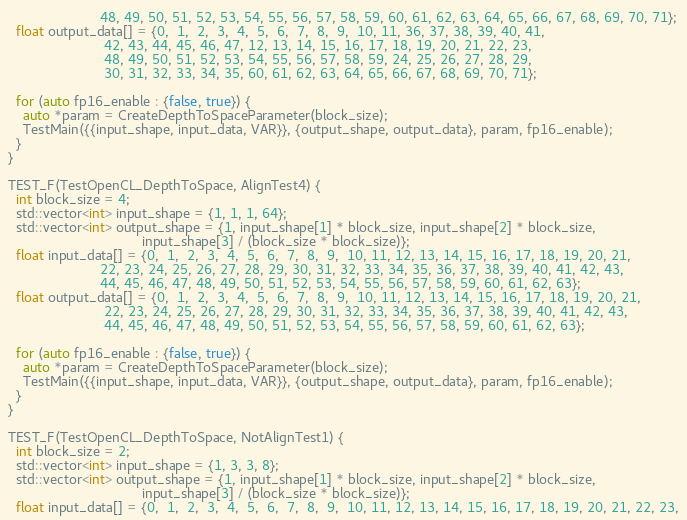<code> <loc_0><loc_0><loc_500><loc_500><_C++_>                        48, 49, 50, 51, 52, 53, 54, 55, 56, 57, 58, 59, 60, 61, 62, 63, 64, 65, 66, 67, 68, 69, 70, 71};
  float output_data[] = {0,  1,  2,  3,  4,  5,  6,  7,  8,  9,  10, 11, 36, 37, 38, 39, 40, 41,
                         42, 43, 44, 45, 46, 47, 12, 13, 14, 15, 16, 17, 18, 19, 20, 21, 22, 23,
                         48, 49, 50, 51, 52, 53, 54, 55, 56, 57, 58, 59, 24, 25, 26, 27, 28, 29,
                         30, 31, 32, 33, 34, 35, 60, 61, 62, 63, 64, 65, 66, 67, 68, 69, 70, 71};

  for (auto fp16_enable : {false, true}) {
    auto *param = CreateDepthToSpaceParameter(block_size);
    TestMain({{input_shape, input_data, VAR}}, {output_shape, output_data}, param, fp16_enable);
  }
}

TEST_F(TestOpenCL_DepthToSpace, AlignTest4) {
  int block_size = 4;
  std::vector<int> input_shape = {1, 1, 1, 64};
  std::vector<int> output_shape = {1, input_shape[1] * block_size, input_shape[2] * block_size,
                                   input_shape[3] / (block_size * block_size)};
  float input_data[] = {0,  1,  2,  3,  4,  5,  6,  7,  8,  9,  10, 11, 12, 13, 14, 15, 16, 17, 18, 19, 20, 21,
                        22, 23, 24, 25, 26, 27, 28, 29, 30, 31, 32, 33, 34, 35, 36, 37, 38, 39, 40, 41, 42, 43,
                        44, 45, 46, 47, 48, 49, 50, 51, 52, 53, 54, 55, 56, 57, 58, 59, 60, 61, 62, 63};
  float output_data[] = {0,  1,  2,  3,  4,  5,  6,  7,  8,  9,  10, 11, 12, 13, 14, 15, 16, 17, 18, 19, 20, 21,
                         22, 23, 24, 25, 26, 27, 28, 29, 30, 31, 32, 33, 34, 35, 36, 37, 38, 39, 40, 41, 42, 43,
                         44, 45, 46, 47, 48, 49, 50, 51, 52, 53, 54, 55, 56, 57, 58, 59, 60, 61, 62, 63};

  for (auto fp16_enable : {false, true}) {
    auto *param = CreateDepthToSpaceParameter(block_size);
    TestMain({{input_shape, input_data, VAR}}, {output_shape, output_data}, param, fp16_enable);
  }
}

TEST_F(TestOpenCL_DepthToSpace, NotAlignTest1) {
  int block_size = 2;
  std::vector<int> input_shape = {1, 3, 3, 8};
  std::vector<int> output_shape = {1, input_shape[1] * block_size, input_shape[2] * block_size,
                                   input_shape[3] / (block_size * block_size)};
  float input_data[] = {0,  1,  2,  3,  4,  5,  6,  7,  8,  9,  10, 11, 12, 13, 14, 15, 16, 17, 18, 19, 20, 21, 22, 23,</code> 